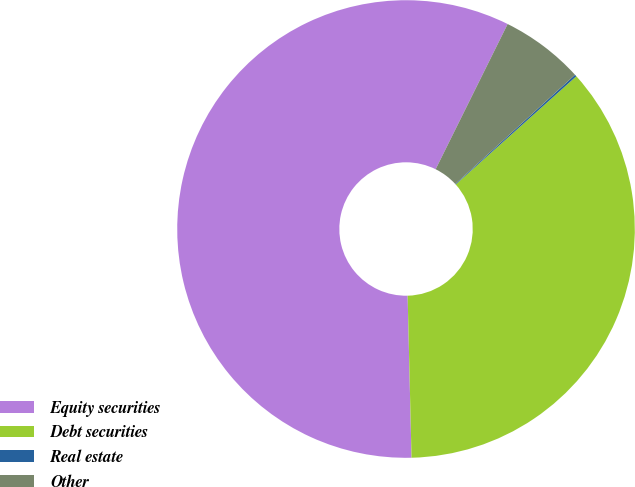<chart> <loc_0><loc_0><loc_500><loc_500><pie_chart><fcel>Equity securities<fcel>Debt securities<fcel>Real estate<fcel>Other<nl><fcel>57.71%<fcel>36.25%<fcel>0.14%<fcel>5.9%<nl></chart> 